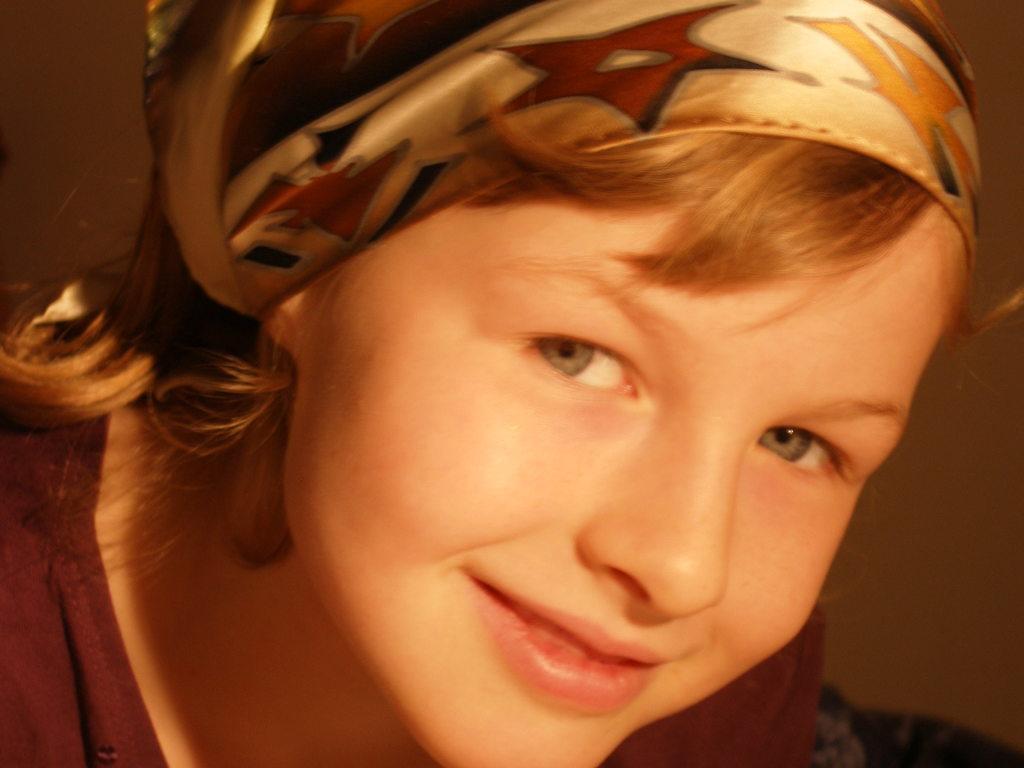Describe this image in one or two sentences. In the middle of this image, there is a woman in brown color T-shirt, smiling. And the background is dark in color. 